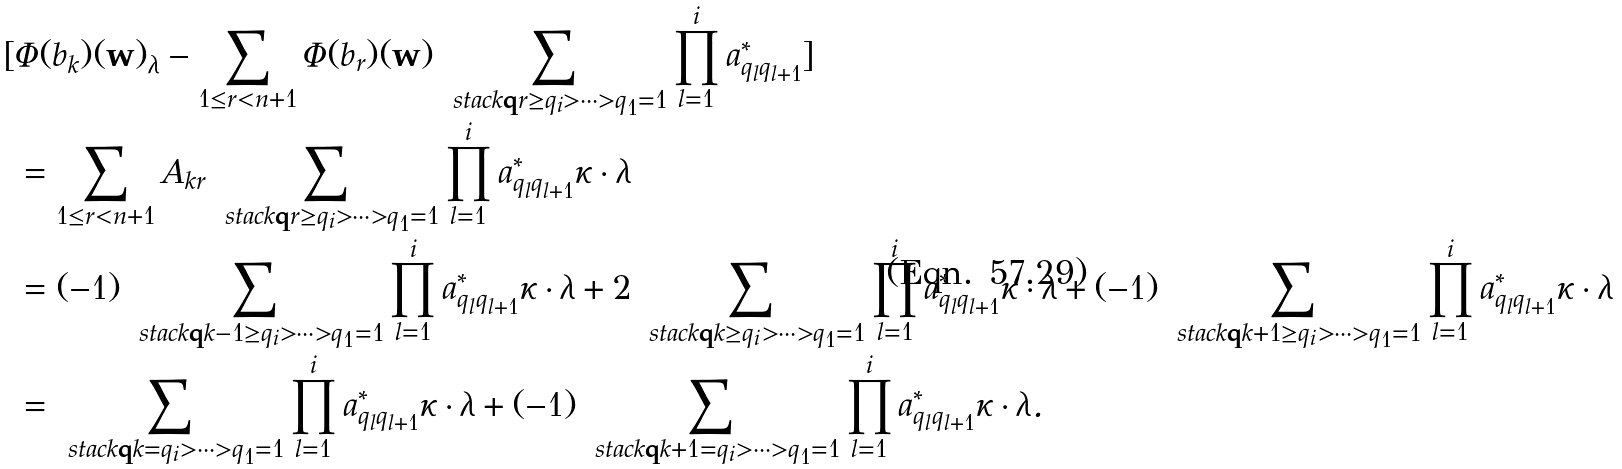<formula> <loc_0><loc_0><loc_500><loc_500>[ & \Phi ( b _ { k } ) ( \mathbf w ) _ { \lambda } - \sum _ { 1 \leq r < n + 1 } \Phi ( b _ { r } ) ( \mathbf w ) \sum _ { \ s t a c k { \mathbf q } { r \geq q _ { i } > \cdots > q _ { 1 } = 1 } } \prod _ { l = 1 } ^ { i } a _ { q _ { l } q _ { l + 1 } } ^ { * } ] \\ & = \sum _ { 1 \leq r < n + 1 } A _ { k r } \sum _ { \ s t a c k { \mathbf q } { r \geq q _ { i } > \cdots > q _ { 1 } = 1 } } \prod _ { l = 1 } ^ { i } a _ { q _ { l } q _ { l + 1 } } ^ { * } \kappa \cdot { \lambda } \\ & = ( - 1 ) \sum _ { \ s t a c k { \mathbf q } { k - 1 \geq q _ { i } > \cdots > q _ { 1 } = 1 } } \prod _ { l = 1 } ^ { i } a _ { q _ { l } q _ { l + 1 } } ^ { * } \kappa \cdot { \lambda } + 2 \sum _ { \ s t a c k { \mathbf q } { k \geq q _ { i } > \cdots > q _ { 1 } = 1 } } \prod _ { l = 1 } ^ { i } a _ { q _ { l } q _ { l + 1 } } ^ { * } \kappa \cdot { \lambda } + ( - 1 ) \sum _ { \ s t a c k { \mathbf q } { k + 1 \geq q _ { i } > \cdots > q _ { 1 } = 1 } } \prod _ { l = 1 } ^ { i } a _ { q _ { l } q _ { l + 1 } } ^ { * } \kappa \cdot { \lambda } \\ & = \sum _ { \ s t a c k { \mathbf q } { k = q _ { i } > \cdots > q _ { 1 } = 1 } } \prod _ { l = 1 } ^ { i } a _ { q _ { l } q _ { l + 1 } } ^ { * } \kappa \cdot { \lambda } + ( - 1 ) \sum _ { \ s t a c k { \mathbf q } { k + 1 = q _ { i } > \cdots > q _ { 1 } = 1 } } \prod _ { l = 1 } ^ { i } a _ { q _ { l } q _ { l + 1 } } ^ { * } \kappa \cdot { \lambda } .</formula> 